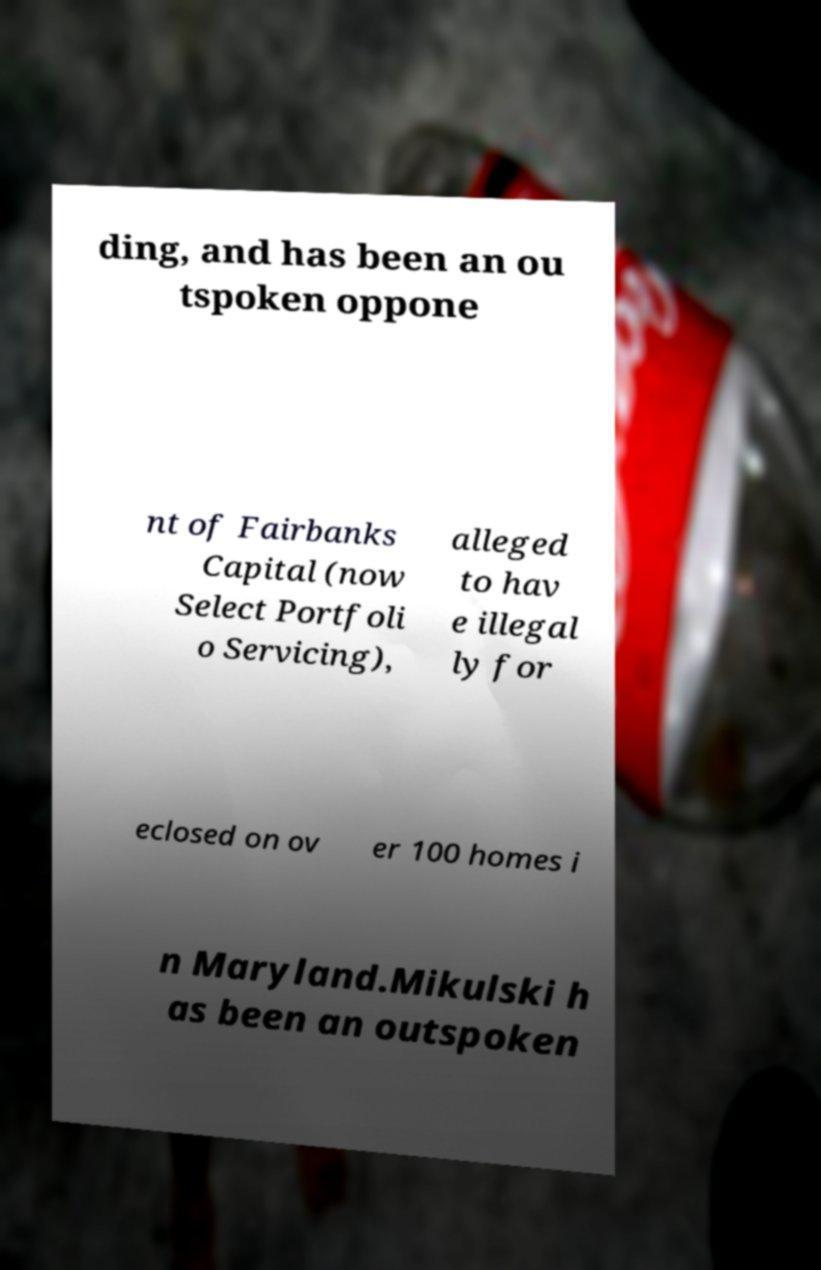There's text embedded in this image that I need extracted. Can you transcribe it verbatim? ding, and has been an ou tspoken oppone nt of Fairbanks Capital (now Select Portfoli o Servicing), alleged to hav e illegal ly for eclosed on ov er 100 homes i n Maryland.Mikulski h as been an outspoken 